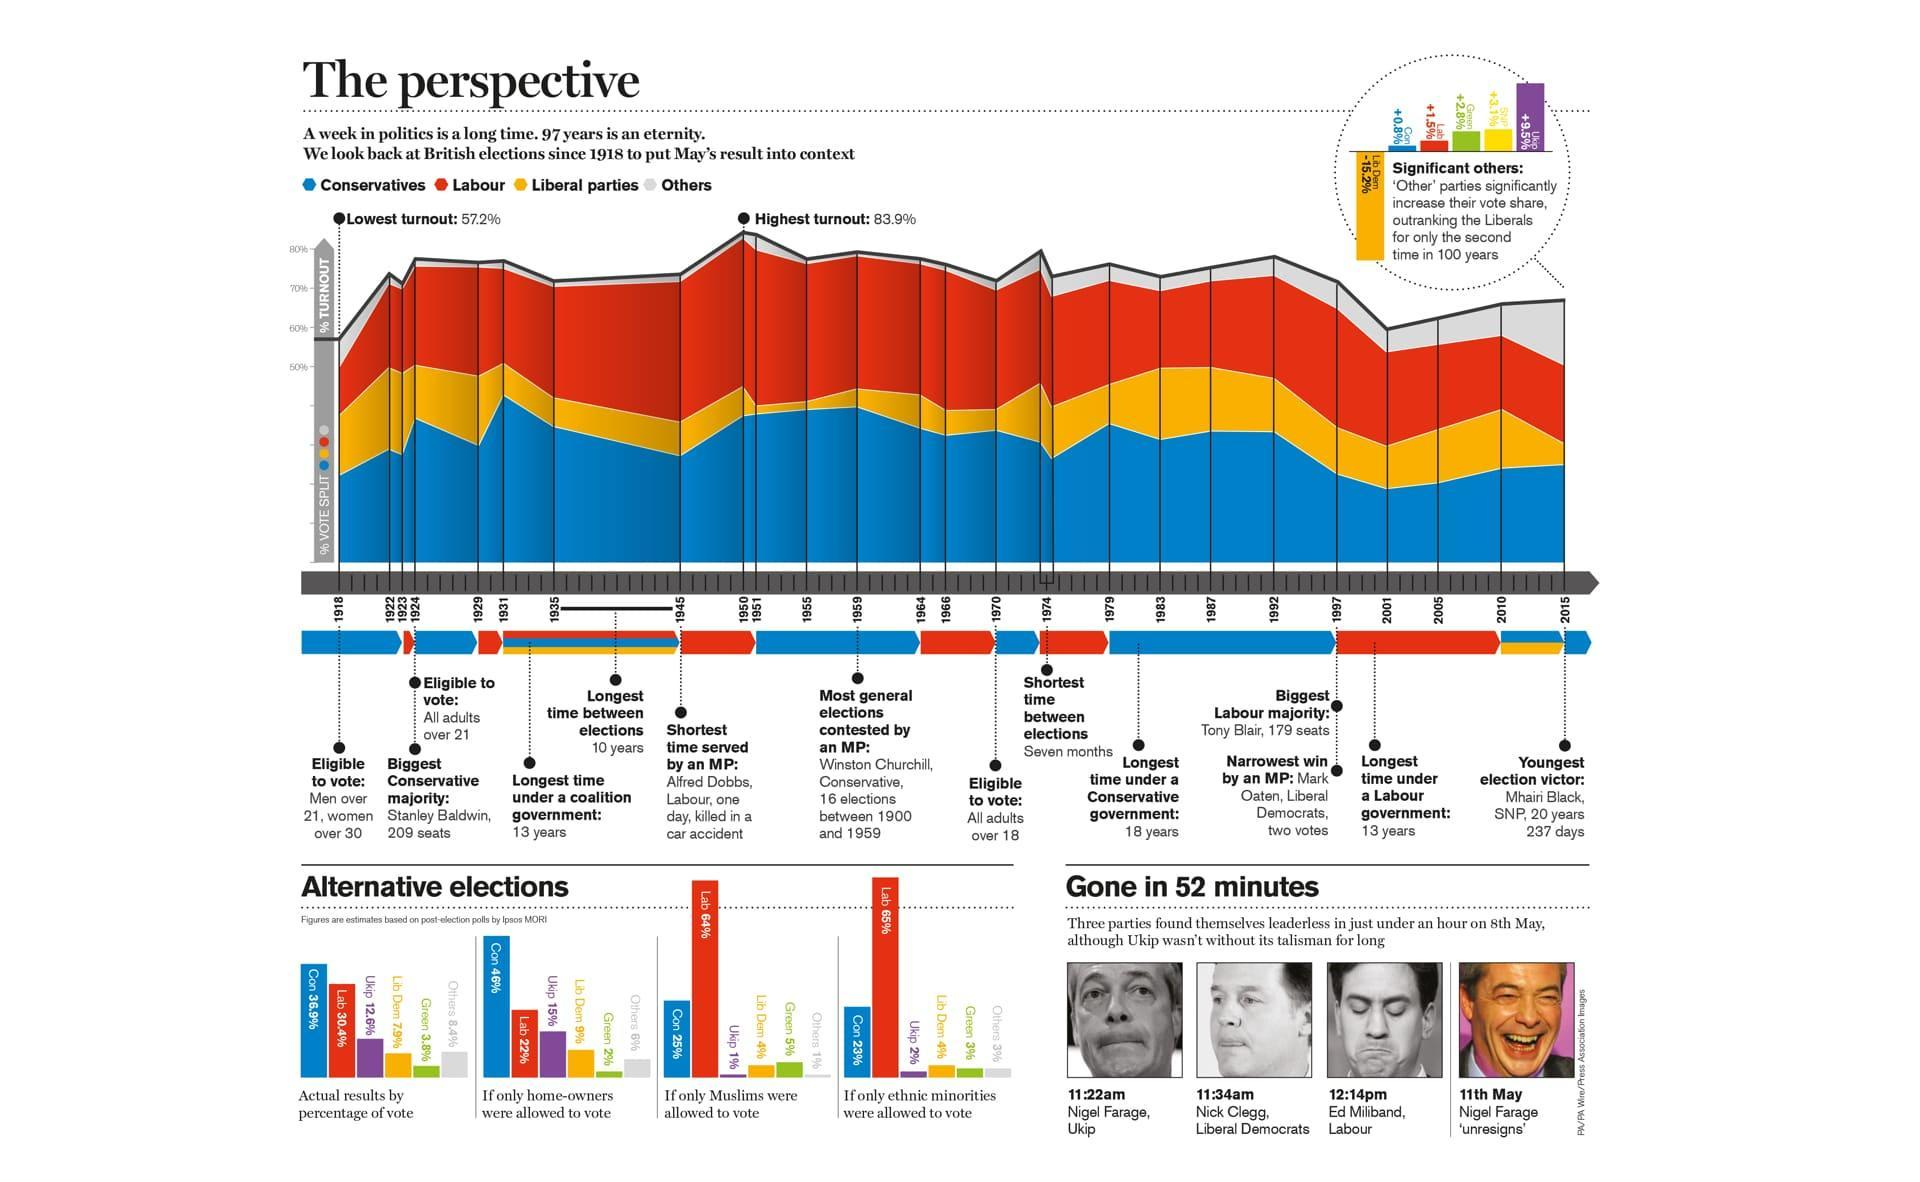What is the estimated percentage of votes received by the Conservative party in UK if only Muslims were allowed to vote?
Answer the question with a short phrase. 25% What is the longest time between elections in UK since 1918? 10 years What is the shortest time between elections in UK since 1918? Seven months What was the voting age of women in UK in 1981? over 30 What is the longest time under a labour government in UK? 13 years What is the estimated percentage of votes received by the Labour party in UK if only ethnic minorities were allowed to vote? 65% What is the estimated percentage of votes received by the Conservative party in UK if only home-owners were allowed to vote? 46% Who has won the biggest labour majority in UK general election in 1997? Tony Blair 